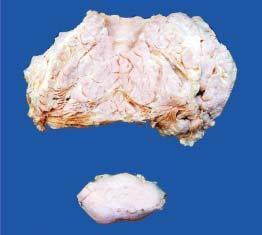what shows circumscribed?
Answer the question using a single word or phrase. Cut surface of both the masses 